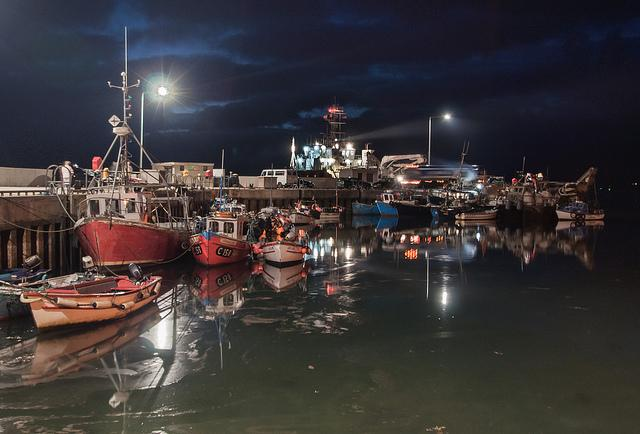What do the small floats on the boats sides here meant to prevent the boats doing?

Choices:
A) getting lost
B) soaring
C) bumping
D) sinking bumping 